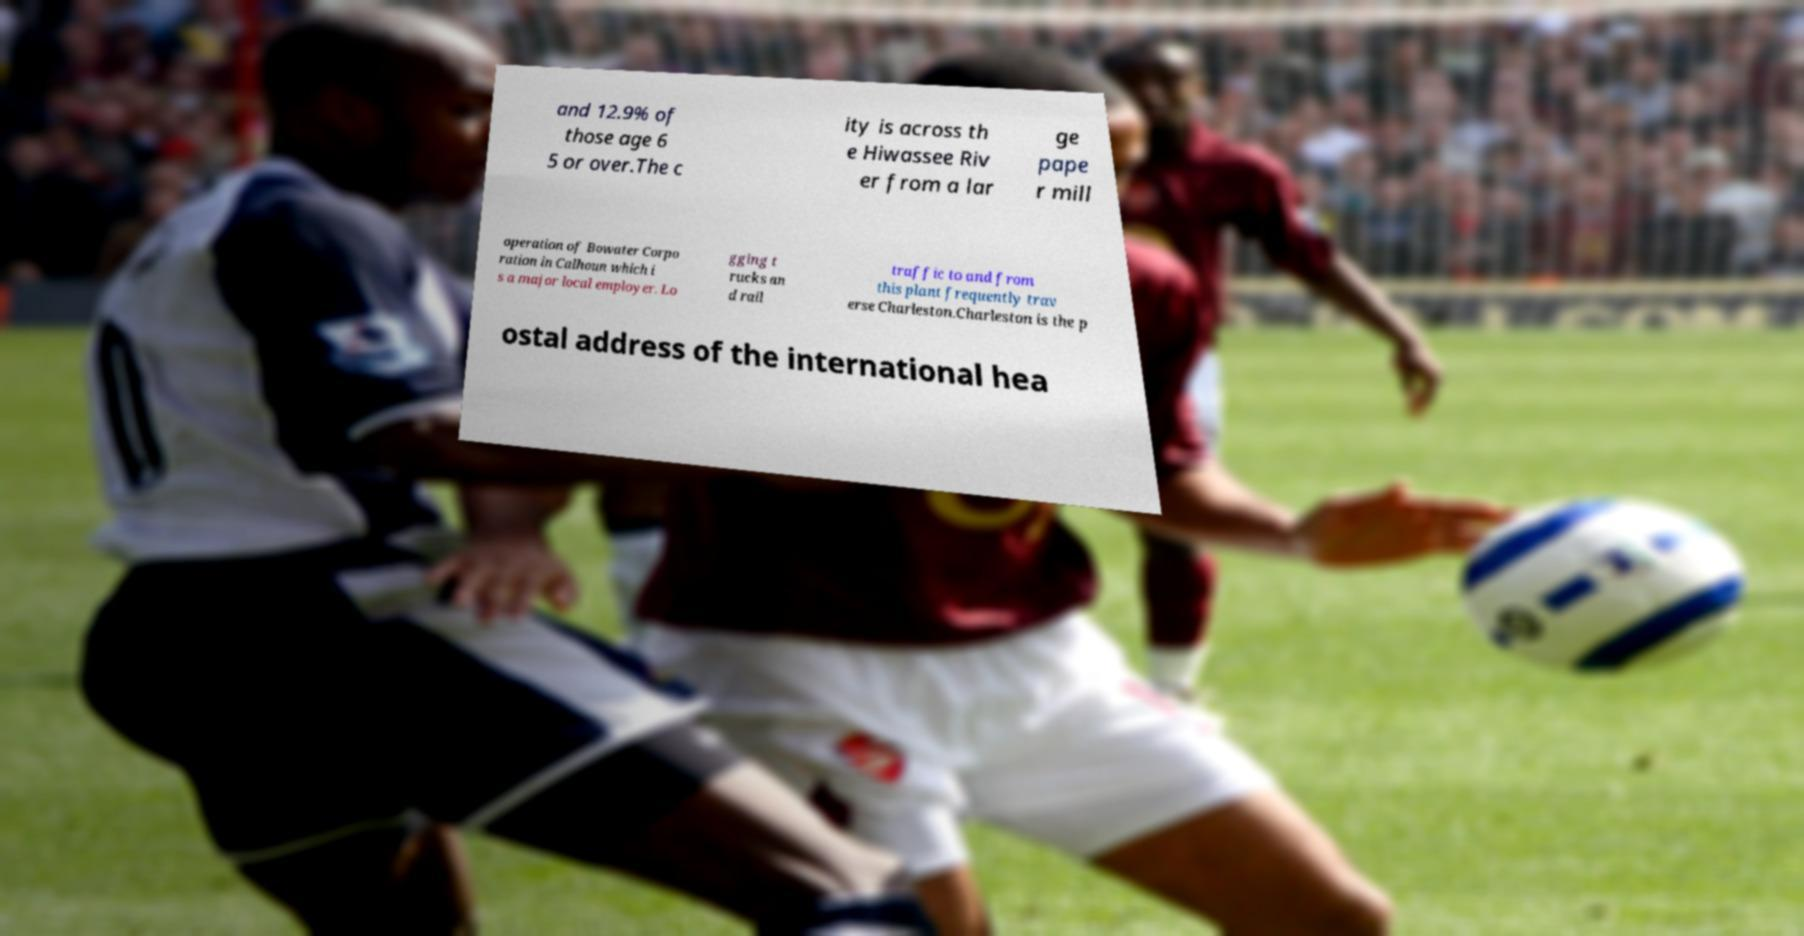I need the written content from this picture converted into text. Can you do that? and 12.9% of those age 6 5 or over.The c ity is across th e Hiwassee Riv er from a lar ge pape r mill operation of Bowater Corpo ration in Calhoun which i s a major local employer. Lo gging t rucks an d rail traffic to and from this plant frequently trav erse Charleston.Charleston is the p ostal address of the international hea 